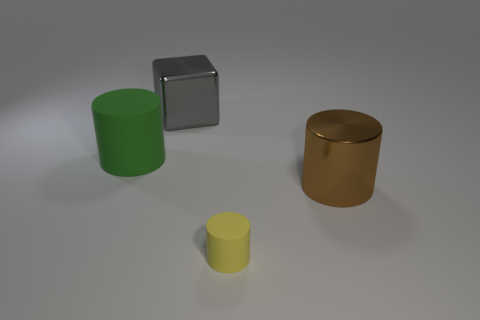Is there a cube that is in front of the metallic object that is in front of the big green rubber cylinder?
Provide a succinct answer. No. How many blue shiny balls are there?
Provide a short and direct response. 0. There is a large matte cylinder; does it have the same color as the object right of the tiny yellow cylinder?
Offer a terse response. No. Are there more large purple metal blocks than shiny cubes?
Provide a succinct answer. No. Is there any other thing that has the same color as the large cube?
Your response must be concise. No. What number of other things are the same size as the block?
Provide a short and direct response. 2. What material is the large cylinder behind the thing that is to the right of the rubber object that is in front of the large green rubber thing?
Provide a succinct answer. Rubber. Do the yellow thing and the big cylinder in front of the large green cylinder have the same material?
Make the answer very short. No. Is the number of yellow things that are in front of the large green object less than the number of metallic things that are to the left of the gray cube?
Keep it short and to the point. No. How many big cyan cylinders are the same material as the cube?
Provide a short and direct response. 0. 